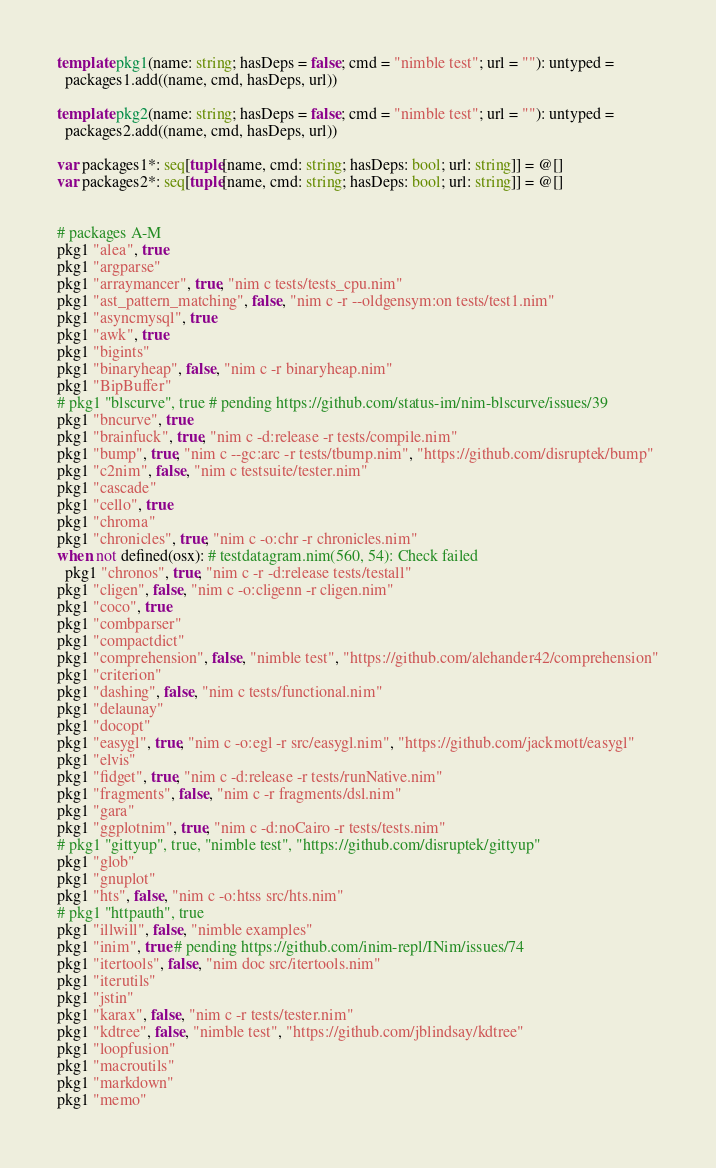<code> <loc_0><loc_0><loc_500><loc_500><_Nim_>template pkg1(name: string; hasDeps = false; cmd = "nimble test"; url = ""): untyped =
  packages1.add((name, cmd, hasDeps, url))

template pkg2(name: string; hasDeps = false; cmd = "nimble test"; url = ""): untyped =
  packages2.add((name, cmd, hasDeps, url))

var packages1*: seq[tuple[name, cmd: string; hasDeps: bool; url: string]] = @[]
var packages2*: seq[tuple[name, cmd: string; hasDeps: bool; url: string]] = @[]


# packages A-M
pkg1 "alea", true
pkg1 "argparse"
pkg1 "arraymancer", true, "nim c tests/tests_cpu.nim"
pkg1 "ast_pattern_matching", false, "nim c -r --oldgensym:on tests/test1.nim"
pkg1 "asyncmysql", true
pkg1 "awk", true
pkg1 "bigints"
pkg1 "binaryheap", false, "nim c -r binaryheap.nim"
pkg1 "BipBuffer"
# pkg1 "blscurve", true # pending https://github.com/status-im/nim-blscurve/issues/39
pkg1 "bncurve", true
pkg1 "brainfuck", true, "nim c -d:release -r tests/compile.nim"
pkg1 "bump", true, "nim c --gc:arc -r tests/tbump.nim", "https://github.com/disruptek/bump"
pkg1 "c2nim", false, "nim c testsuite/tester.nim"
pkg1 "cascade"
pkg1 "cello", true
pkg1 "chroma"
pkg1 "chronicles", true, "nim c -o:chr -r chronicles.nim"
when not defined(osx): # testdatagram.nim(560, 54): Check failed
  pkg1 "chronos", true, "nim c -r -d:release tests/testall"
pkg1 "cligen", false, "nim c -o:cligenn -r cligen.nim"
pkg1 "coco", true
pkg1 "combparser"
pkg1 "compactdict"
pkg1 "comprehension", false, "nimble test", "https://github.com/alehander42/comprehension"
pkg1 "criterion"
pkg1 "dashing", false, "nim c tests/functional.nim"
pkg1 "delaunay"
pkg1 "docopt"
pkg1 "easygl", true, "nim c -o:egl -r src/easygl.nim", "https://github.com/jackmott/easygl"
pkg1 "elvis"
pkg1 "fidget", true, "nim c -d:release -r tests/runNative.nim"
pkg1 "fragments", false, "nim c -r fragments/dsl.nim"
pkg1 "gara"
pkg1 "ggplotnim", true, "nim c -d:noCairo -r tests/tests.nim"
# pkg1 "gittyup", true, "nimble test", "https://github.com/disruptek/gittyup"
pkg1 "glob"
pkg1 "gnuplot"
pkg1 "hts", false, "nim c -o:htss src/hts.nim"
# pkg1 "httpauth", true
pkg1 "illwill", false, "nimble examples"
pkg1 "inim", true # pending https://github.com/inim-repl/INim/issues/74
pkg1 "itertools", false, "nim doc src/itertools.nim"
pkg1 "iterutils"
pkg1 "jstin"
pkg1 "karax", false, "nim c -r tests/tester.nim"
pkg1 "kdtree", false, "nimble test", "https://github.com/jblindsay/kdtree"
pkg1 "loopfusion"
pkg1 "macroutils"
pkg1 "markdown"
pkg1 "memo"</code> 